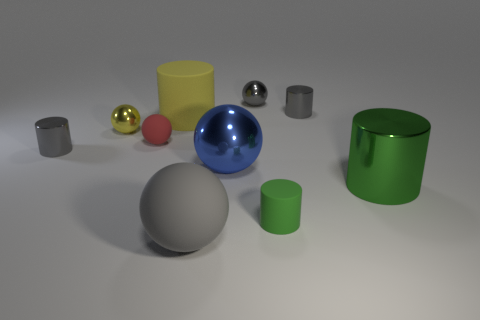Subtract 2 balls. How many balls are left? 3 Subtract all big rubber cylinders. How many cylinders are left? 4 Subtract all red balls. How many balls are left? 4 Subtract all brown cylinders. Subtract all red balls. How many cylinders are left? 5 Subtract all spheres. Subtract all big metal spheres. How many objects are left? 4 Add 4 gray cylinders. How many gray cylinders are left? 6 Add 4 big gray matte balls. How many big gray matte balls exist? 5 Subtract 2 gray spheres. How many objects are left? 8 